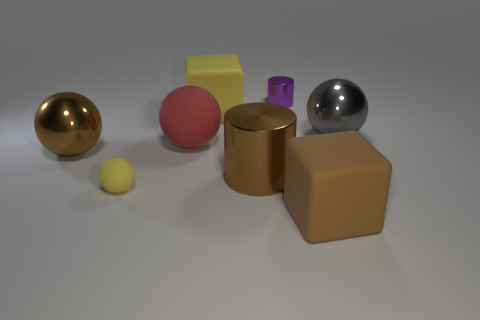Is there any indication of size scale or reference in the image that could help us determine the actual size of these objects? The image does not provide a clear reference point for scale, such as a recognizable object with known dimensions. Therefore, we cannot accurately determine the actual size of these objects without additional context or measurement indicators. 